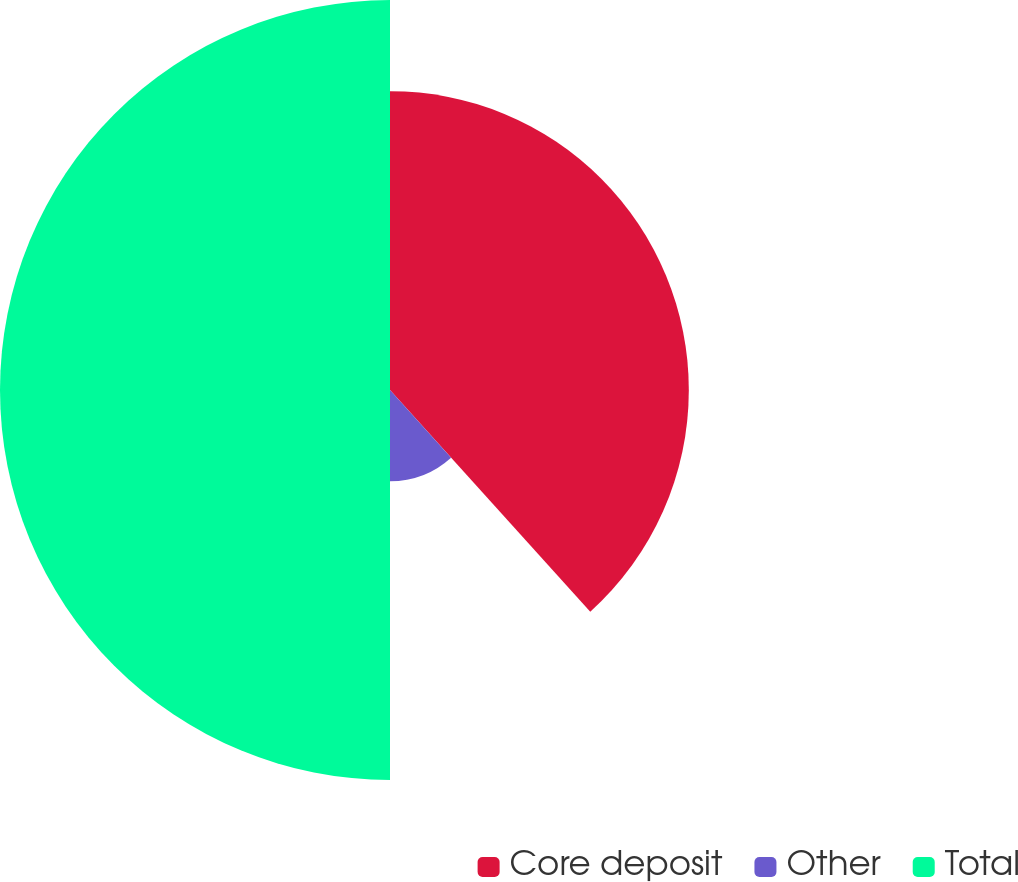Convert chart. <chart><loc_0><loc_0><loc_500><loc_500><pie_chart><fcel>Core deposit<fcel>Other<fcel>Total<nl><fcel>38.31%<fcel>11.69%<fcel>50.0%<nl></chart> 